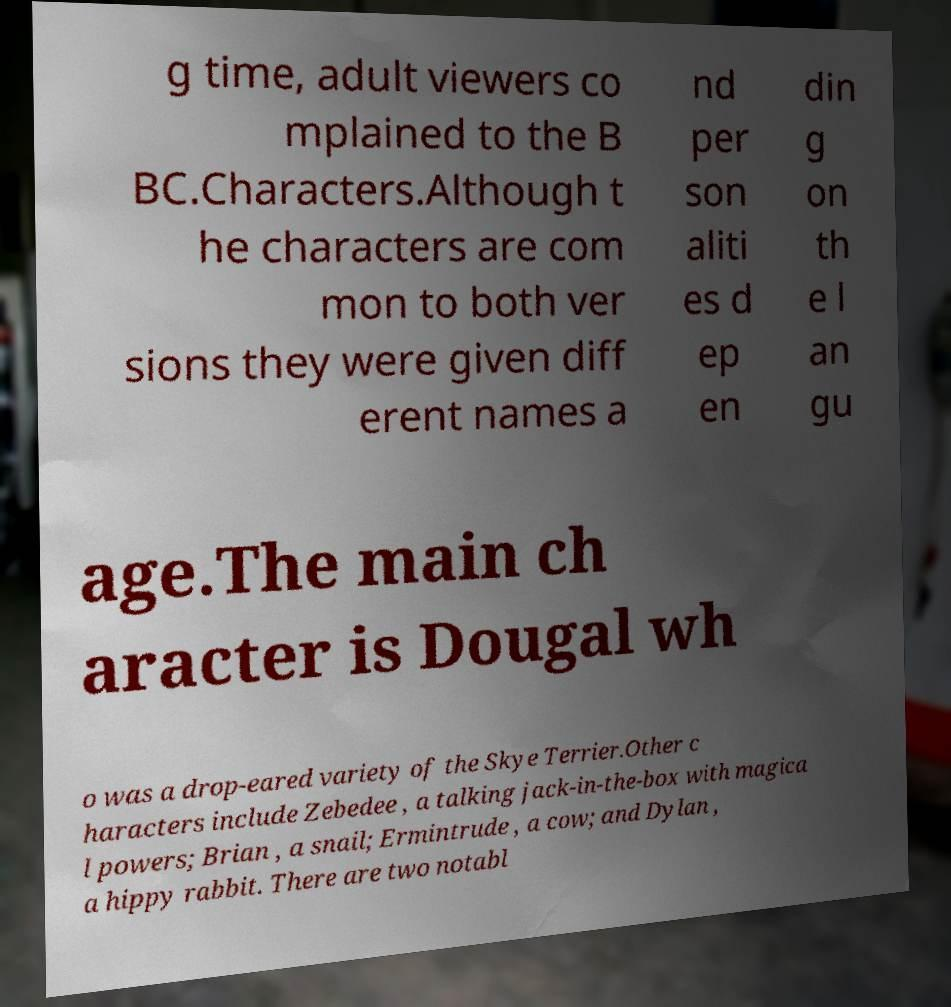Can you accurately transcribe the text from the provided image for me? g time, adult viewers co mplained to the B BC.Characters.Although t he characters are com mon to both ver sions they were given diff erent names a nd per son aliti es d ep en din g on th e l an gu age.The main ch aracter is Dougal wh o was a drop-eared variety of the Skye Terrier.Other c haracters include Zebedee , a talking jack-in-the-box with magica l powers; Brian , a snail; Ermintrude , a cow; and Dylan , a hippy rabbit. There are two notabl 